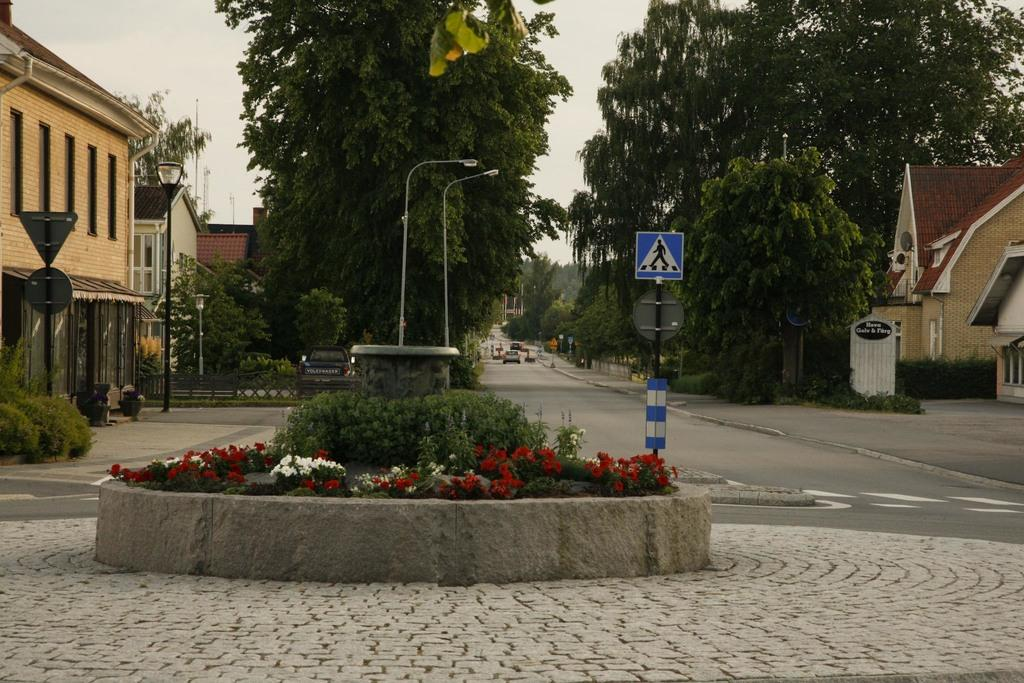What type of structures can be seen in the image? There are buildings in the image. What type of vegetation is present in the image? There are trees, bushes, and shrubs in the image. What type of transportation is visible on the road in the image? There are motor vehicles on the road in the image. What type of street furniture can be seen in the image? There are street poles and street lights in the image. What type of signage is present in the image? There are sign boards in the image. What type of pavement is visible in the image? There is laid stone in the image. What part of the natural environment is visible in the image? The sky is visible in the image. Can you describe the fight between the coat and the pull in the image? There is no fight, coat, or pull present in the image. 